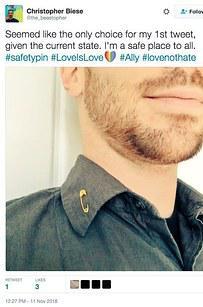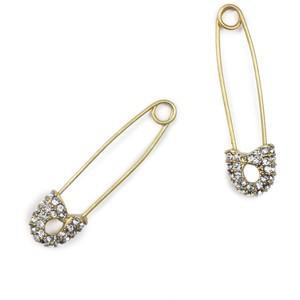The first image is the image on the left, the second image is the image on the right. Analyze the images presented: Is the assertion "In each image, a woman with blonde hair is shown from the side with a small safety pin, clasp end pointed down, being used as a earring." valid? Answer yes or no. No. The first image is the image on the left, the second image is the image on the right. Evaluate the accuracy of this statement regarding the images: "There is a woman wearing a safety pin earring in each image.". Is it true? Answer yes or no. No. 